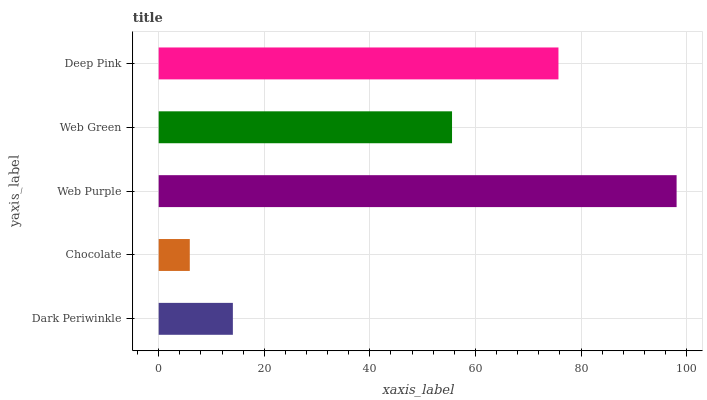Is Chocolate the minimum?
Answer yes or no. Yes. Is Web Purple the maximum?
Answer yes or no. Yes. Is Web Purple the minimum?
Answer yes or no. No. Is Chocolate the maximum?
Answer yes or no. No. Is Web Purple greater than Chocolate?
Answer yes or no. Yes. Is Chocolate less than Web Purple?
Answer yes or no. Yes. Is Chocolate greater than Web Purple?
Answer yes or no. No. Is Web Purple less than Chocolate?
Answer yes or no. No. Is Web Green the high median?
Answer yes or no. Yes. Is Web Green the low median?
Answer yes or no. Yes. Is Dark Periwinkle the high median?
Answer yes or no. No. Is Web Purple the low median?
Answer yes or no. No. 